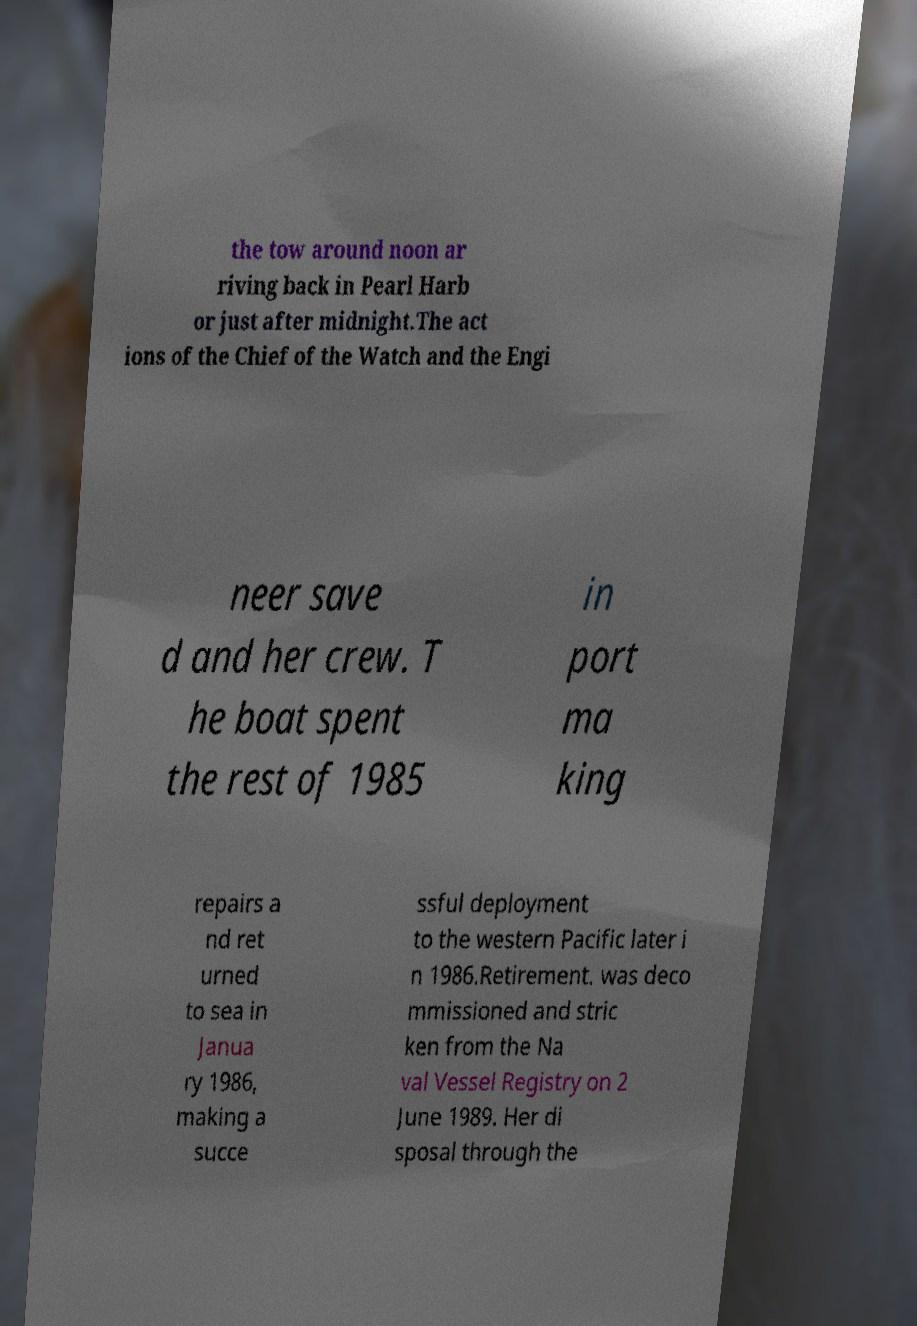Please identify and transcribe the text found in this image. the tow around noon ar riving back in Pearl Harb or just after midnight.The act ions of the Chief of the Watch and the Engi neer save d and her crew. T he boat spent the rest of 1985 in port ma king repairs a nd ret urned to sea in Janua ry 1986, making a succe ssful deployment to the western Pacific later i n 1986.Retirement. was deco mmissioned and stric ken from the Na val Vessel Registry on 2 June 1989. Her di sposal through the 